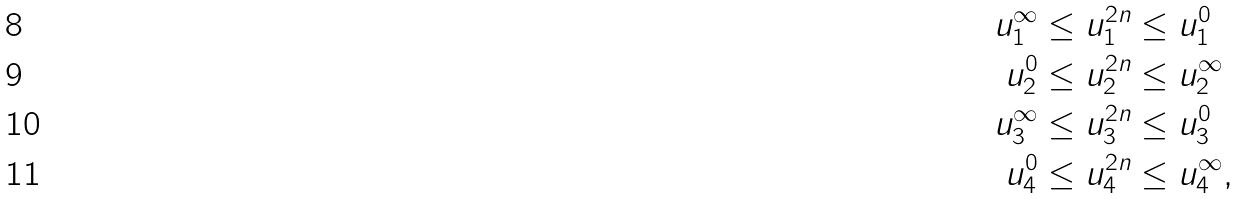<formula> <loc_0><loc_0><loc_500><loc_500>u _ { 1 } ^ { \infty } & \leq u _ { 1 } ^ { 2 n } \leq u _ { 1 } ^ { 0 } \\ u _ { 2 } ^ { 0 } & \leq u _ { 2 } ^ { 2 n } \leq u _ { 2 } ^ { \infty } \\ u _ { 3 } ^ { \infty } & \leq u _ { 3 } ^ { 2 n } \leq u _ { 3 } ^ { 0 } \\ u _ { 4 } ^ { 0 } & \leq u _ { 4 } ^ { 2 n } \leq u _ { 4 } ^ { \infty } ,</formula> 